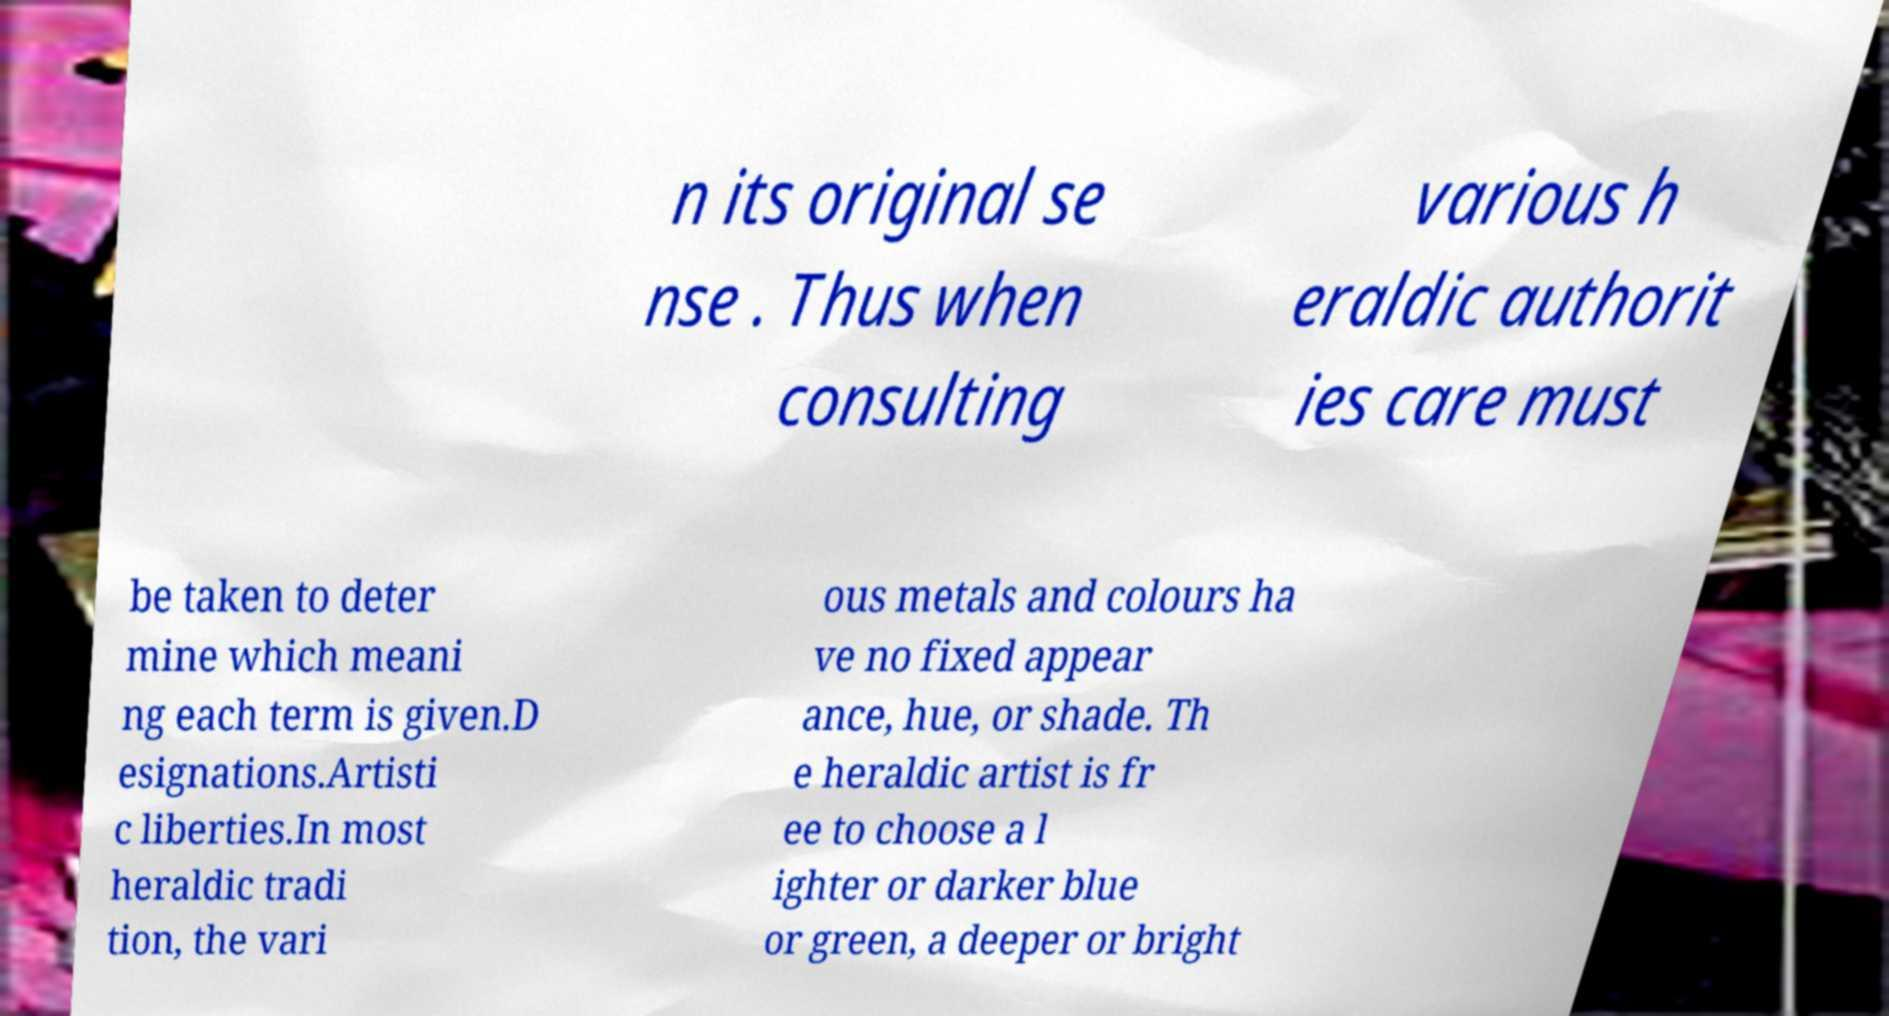Can you read and provide the text displayed in the image?This photo seems to have some interesting text. Can you extract and type it out for me? n its original se nse . Thus when consulting various h eraldic authorit ies care must be taken to deter mine which meani ng each term is given.D esignations.Artisti c liberties.In most heraldic tradi tion, the vari ous metals and colours ha ve no fixed appear ance, hue, or shade. Th e heraldic artist is fr ee to choose a l ighter or darker blue or green, a deeper or bright 